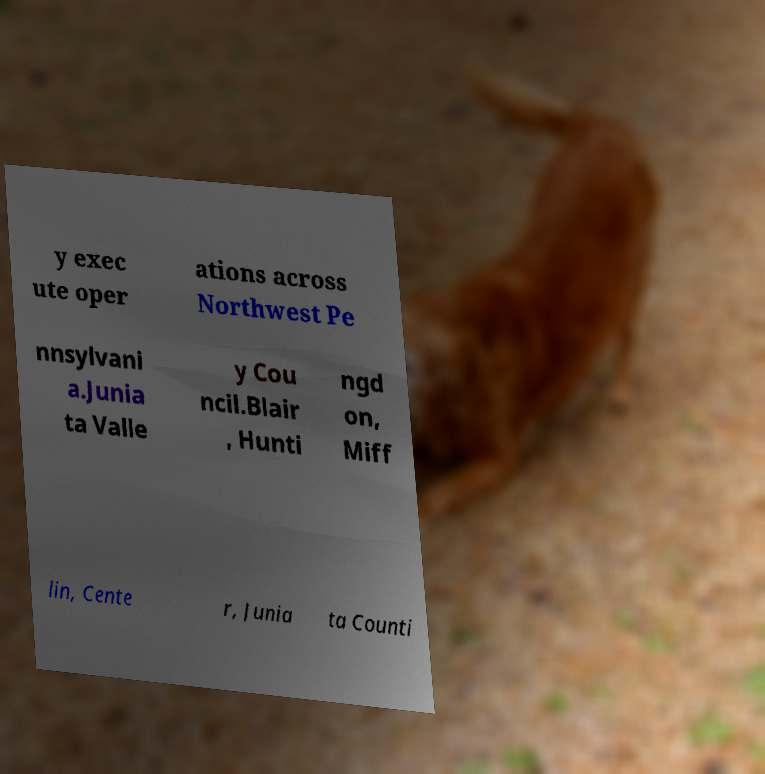I need the written content from this picture converted into text. Can you do that? y exec ute oper ations across Northwest Pe nnsylvani a.Junia ta Valle y Cou ncil.Blair , Hunti ngd on, Miff lin, Cente r, Junia ta Counti 